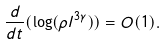<formula> <loc_0><loc_0><loc_500><loc_500>\frac { d } { d t } ( \log ( \rho l ^ { 3 \gamma } ) ) = O ( 1 ) .</formula> 